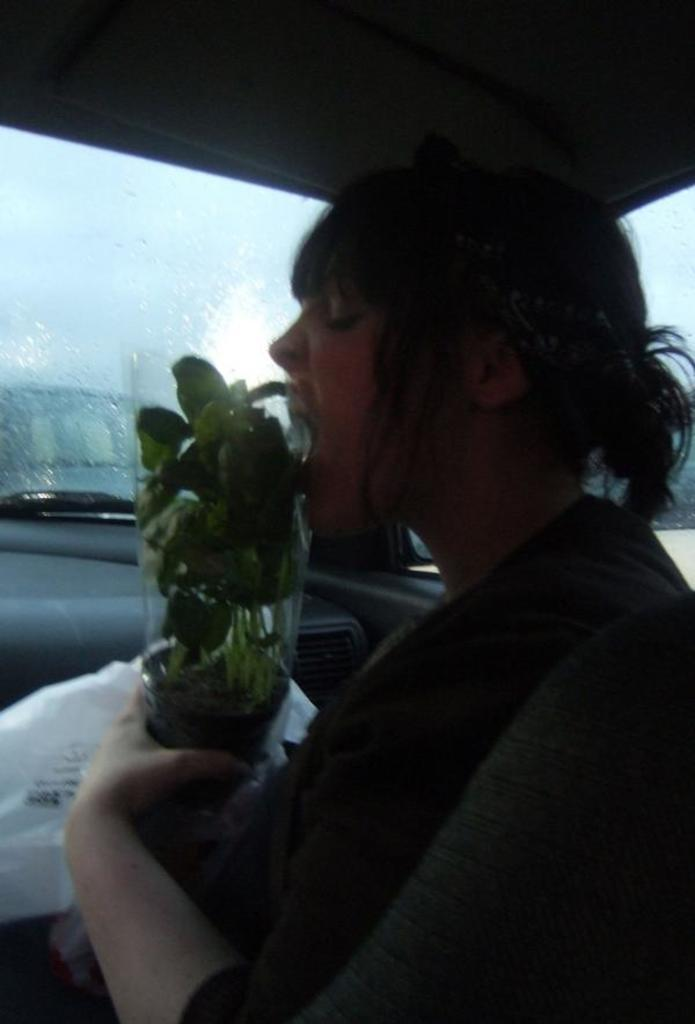Who is present in the image? There is a woman in the image. What is the woman holding? The woman is holding a plant. What can be seen inside the vehicle in the image? There is a plastic cover inside the vehicle in the image. What is visible in the background of the image? The sky is visible in the background of the image. What type of quiver is the woman using to hold the plant in the image? There is no quiver present in the image; the woman is simply holding the plant with her hands. 